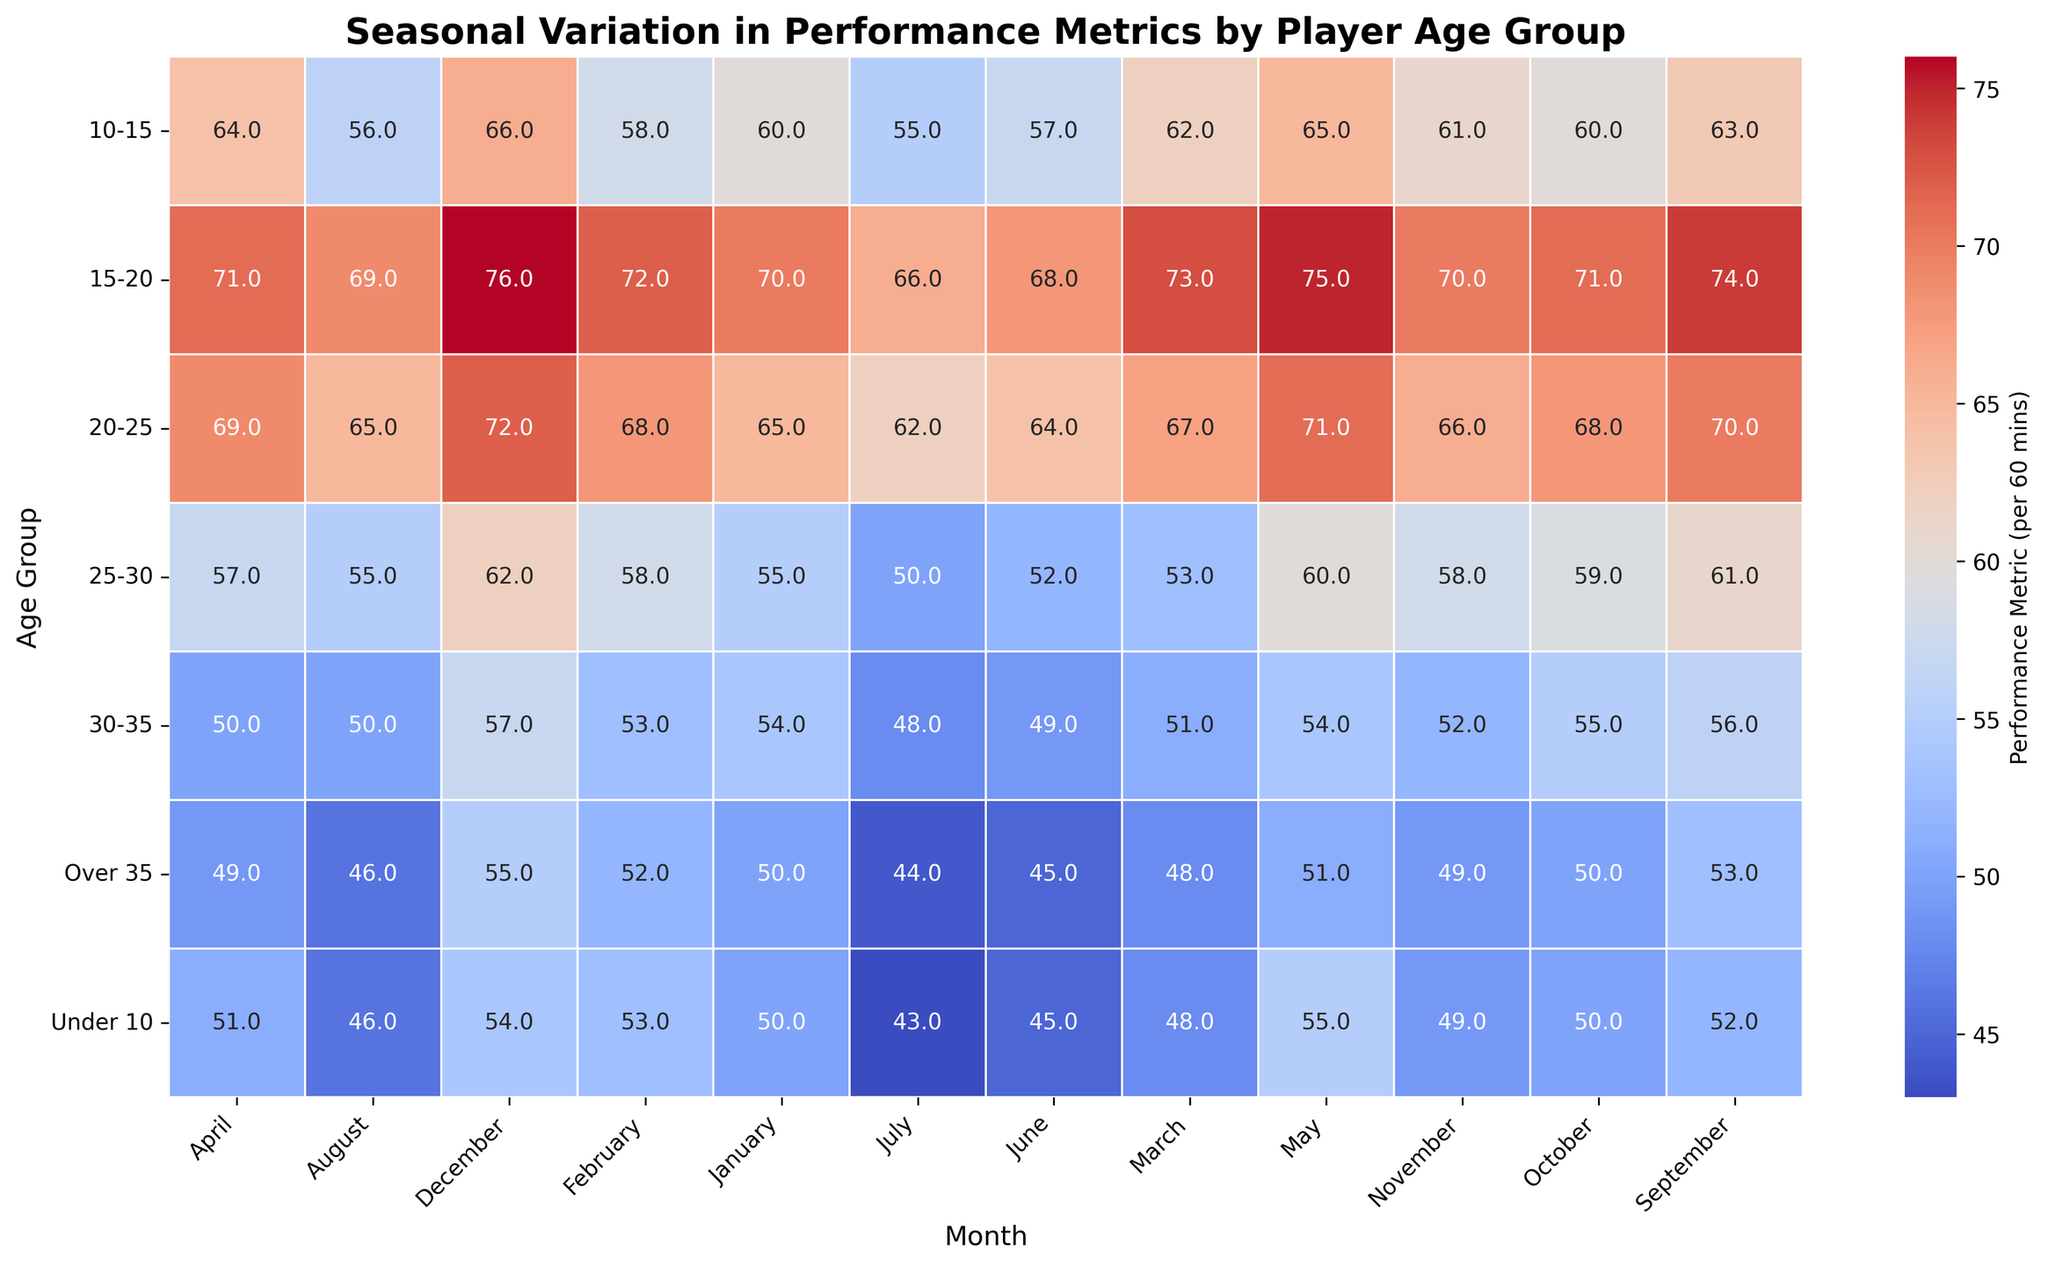Which age group has the highest performance metric in December? To answer this, look at the December column and find the highest value. The highest value in December is 76 in the 15-20 age group.
Answer: 15-20 Which month sees the highest performance metric for the 10-15 age group? Find the row for the 10-15 age group, then identify the maximum value across all months. The maximum value for the 10-15 age group is 66 in December.
Answer: December What is the average performance metric for the age group 20-25 across all months? Sum the performance metrics for each month of the 20-25 age group and divide by the number of months (12). The sum is 775. Average = 775/12 = 64.6.
Answer: 64.6 Compare the performance metrics of the 30-35 age group in January and June. Which month has a higher performance metric? Look at the values for January and June in the 30-35 row. January has 54 and June has 49. January is higher.
Answer: January What is the median performance metric for the age group Under 10? List all the performance metrics for Under 10 across all months: [50, 53, 48, 51, 55, 45, 43, 46, 52, 50, 49, 54]. Order them: [43, 45, 46, 48, 49, 50, 50, 51, 52, 53, 54, 55]. The median is the average of the 6th and 7th values, (50+50)/2 = 50.
Answer: 50 In which month does the Over 35 age group have their lowest performance metric? Look for the minimum value in the Over 35 age group's row. The lowest value is 44 in July.
Answer: July Which age group shows the most variation in performance metrics over the year? To determine the variation, observe the difference between the highest and lowest values for each age group. The age group 15-20 has the highest variation (76 - 66 = 10).
Answer: 15-20 Is there a trend in performance metrics for the Under 10 age group from January to December? Observing the trend in the Under 10 row from January to December, the metrics fluctuate but generally increase from 50 in January to 54 in December.
Answer: Increase Compare the performance metrics in May for age groups 25-30 and 30-35. Which is higher? In May, look at the values for the age groups 25-30 and 30-35. They are 60 and 54 respectively. 25-30 is higher.
Answer: 25-30 What is the sum of performance metrics for the 15-20 age group in January and December? Add the values for January and December for the 15-20 age group, which are 70 and 76. Sum = 70 + 76 = 146.
Answer: 146 